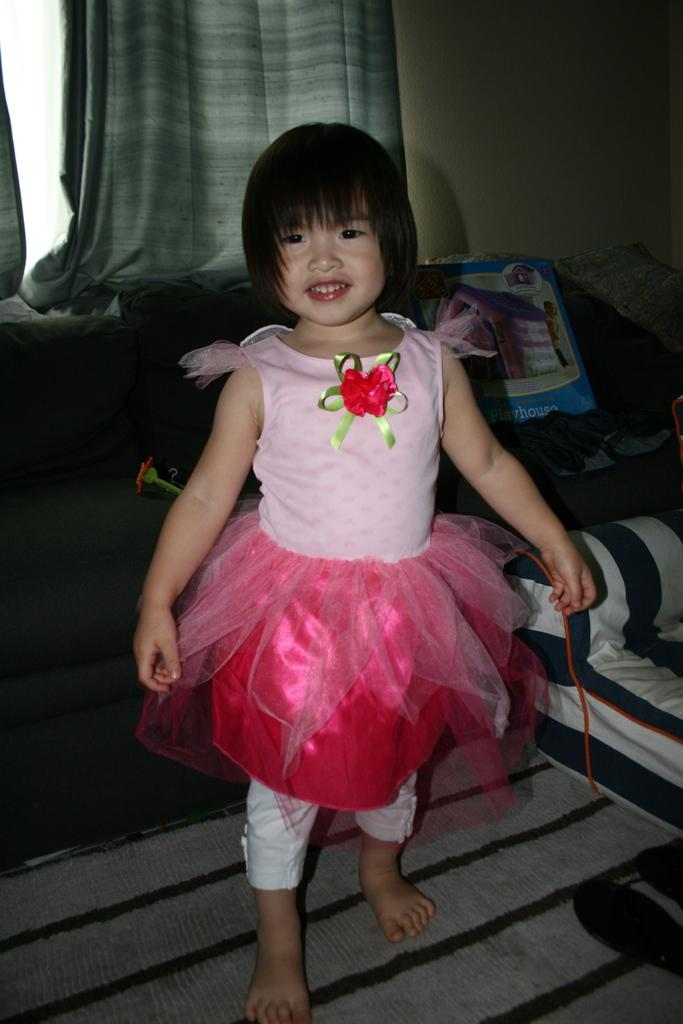Who is the main subject in the image? There is a girl in the image. What is the girl doing in the image? The girl is standing and smiling. What can be seen in the background of the image? There are curtains, a wall, and other objects on the floor in the background of the image. What type of flower is growing near the gate in the image? There is no flower or gate present in the image. What type of medical treatment is the girl receiving in the image? There is no indication of medical treatment or a hospital setting in the image. 